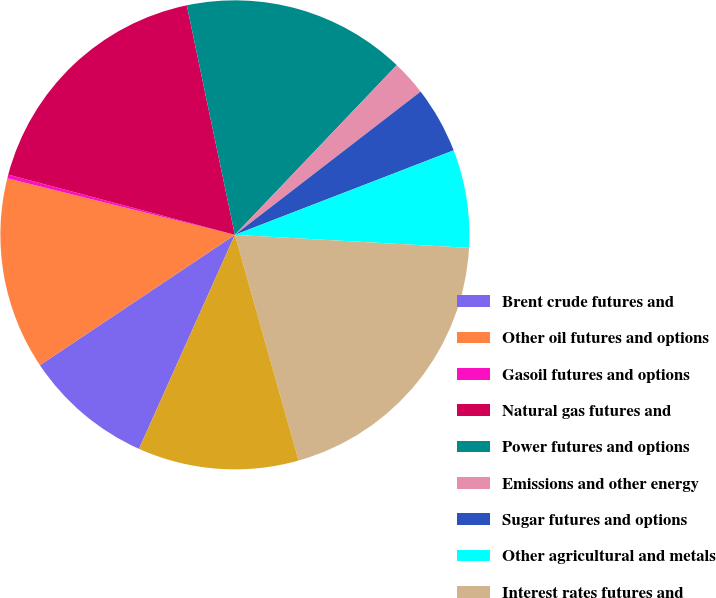Convert chart. <chart><loc_0><loc_0><loc_500><loc_500><pie_chart><fcel>Brent crude futures and<fcel>Other oil futures and options<fcel>Gasoil futures and options<fcel>Natural gas futures and<fcel>Power futures and options<fcel>Emissions and other energy<fcel>Sugar futures and options<fcel>Other agricultural and metals<fcel>Interest rates futures and<fcel>Other financial futures and<nl><fcel>8.92%<fcel>13.25%<fcel>0.26%<fcel>17.58%<fcel>15.41%<fcel>2.42%<fcel>4.59%<fcel>6.75%<fcel>19.74%<fcel>11.08%<nl></chart> 